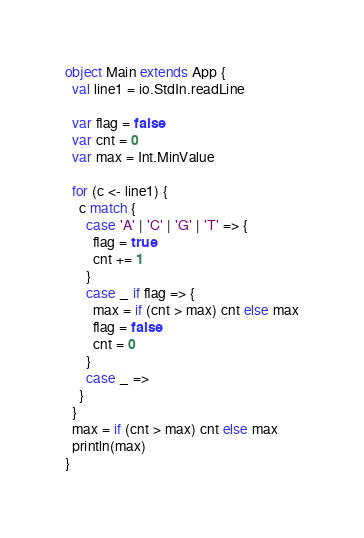Convert code to text. <code><loc_0><loc_0><loc_500><loc_500><_Scala_>object Main extends App {
  val line1 = io.StdIn.readLine

  var flag = false
  var cnt = 0
  var max = Int.MinValue

  for (c <- line1) {
    c match {
      case 'A' | 'C' | 'G' | 'T' => {
        flag = true
        cnt += 1
      }
      case _ if flag => {
        max = if (cnt > max) cnt else max
        flag = false
        cnt = 0
      }
      case _ =>
    }
  }
  max = if (cnt > max) cnt else max
  println(max)
}
</code> 